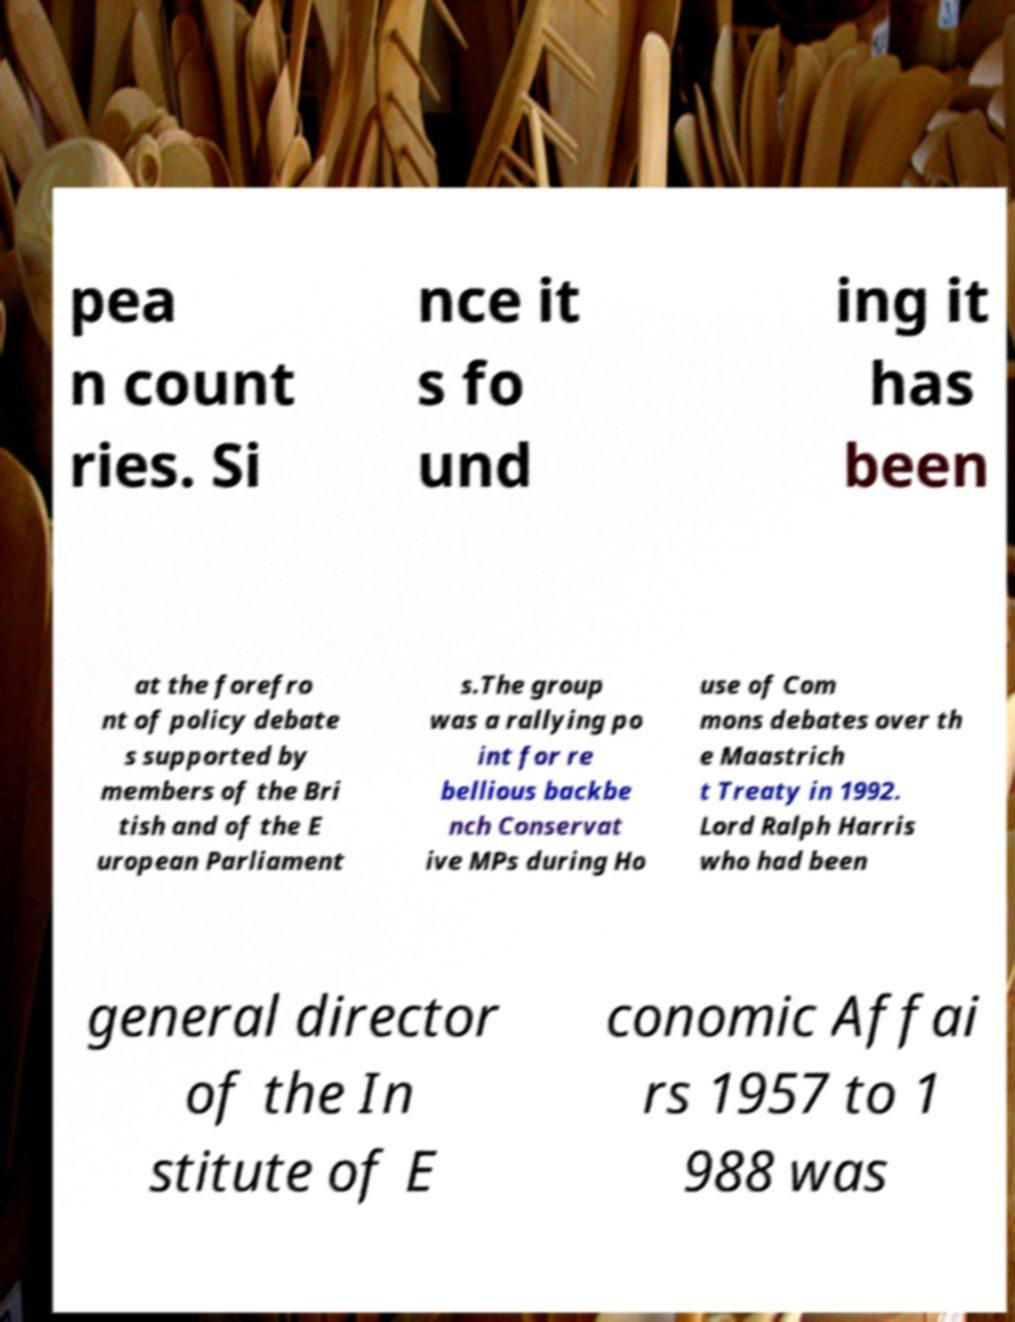Could you assist in decoding the text presented in this image and type it out clearly? pea n count ries. Si nce it s fo und ing it has been at the forefro nt of policy debate s supported by members of the Bri tish and of the E uropean Parliament s.The group was a rallying po int for re bellious backbe nch Conservat ive MPs during Ho use of Com mons debates over th e Maastrich t Treaty in 1992. Lord Ralph Harris who had been general director of the In stitute of E conomic Affai rs 1957 to 1 988 was 